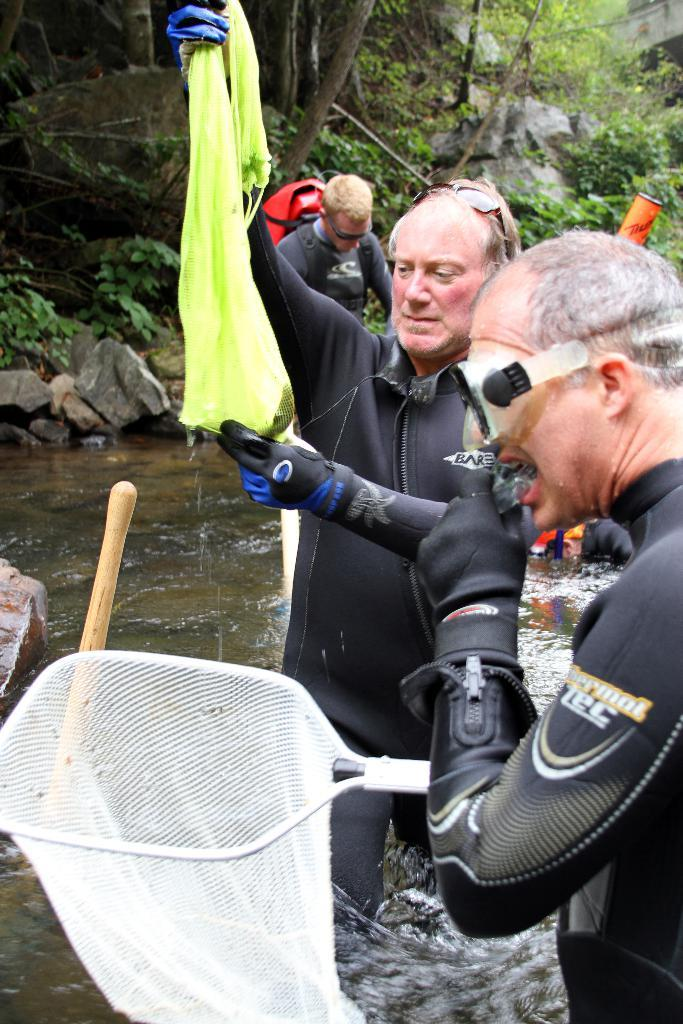How many people are in the image? There are people in the image, but the exact number is not specified. What are the two men holding in the image? The two men are holding objects and standing. What can be seen at the bottom of the image? There is water visible at the bottom of the image. What type of natural environment is visible in the background of the image? Trees, plants, and stones are visible in the background of the image. Can you see any goldfish swimming in the water at the bottom of the image? No, there are no goldfish visible in the water at the bottom of the image. 